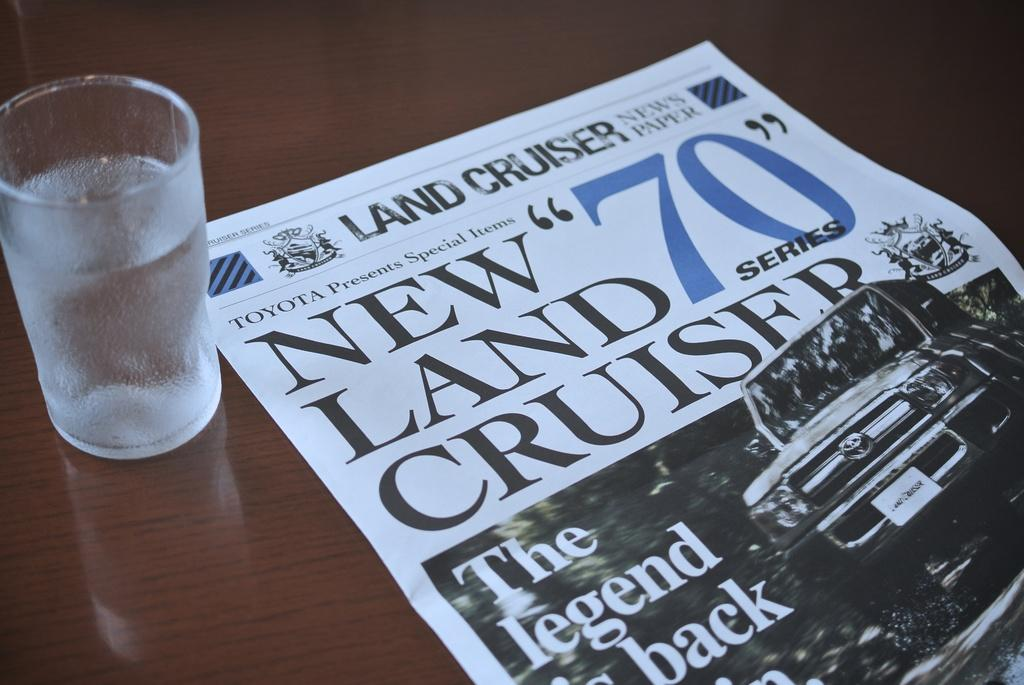<image>
Present a compact description of the photo's key features. a water glass and newspaper that says NEW LAND CRUISERS.. 